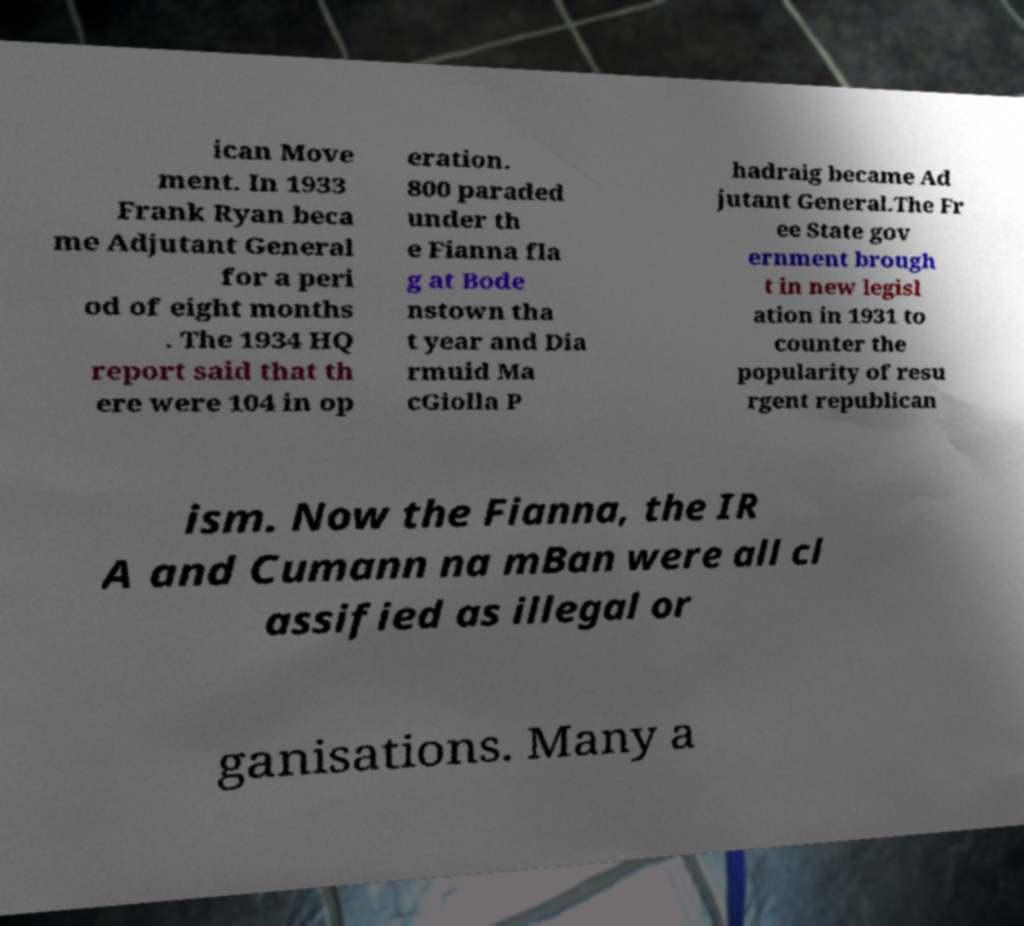For documentation purposes, I need the text within this image transcribed. Could you provide that? ican Move ment. In 1933 Frank Ryan beca me Adjutant General for a peri od of eight months . The 1934 HQ report said that th ere were 104 in op eration. 800 paraded under th e Fianna fla g at Bode nstown tha t year and Dia rmuid Ma cGiolla P hadraig became Ad jutant General.The Fr ee State gov ernment brough t in new legisl ation in 1931 to counter the popularity of resu rgent republican ism. Now the Fianna, the IR A and Cumann na mBan were all cl assified as illegal or ganisations. Many a 